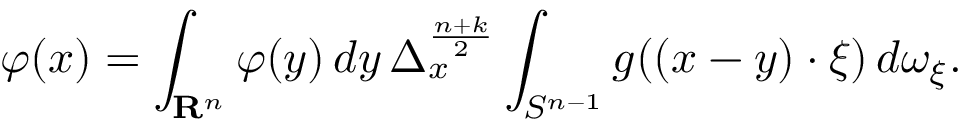<formula> <loc_0><loc_0><loc_500><loc_500>\varphi ( x ) = \int _ { R ^ { n } } \varphi ( y ) \, d y \, \Delta _ { x } ^ { \frac { n + k } { 2 } } \int _ { S ^ { n - 1 } } g ( ( x - y ) \cdot \xi ) \, d \omega _ { \xi } .</formula> 